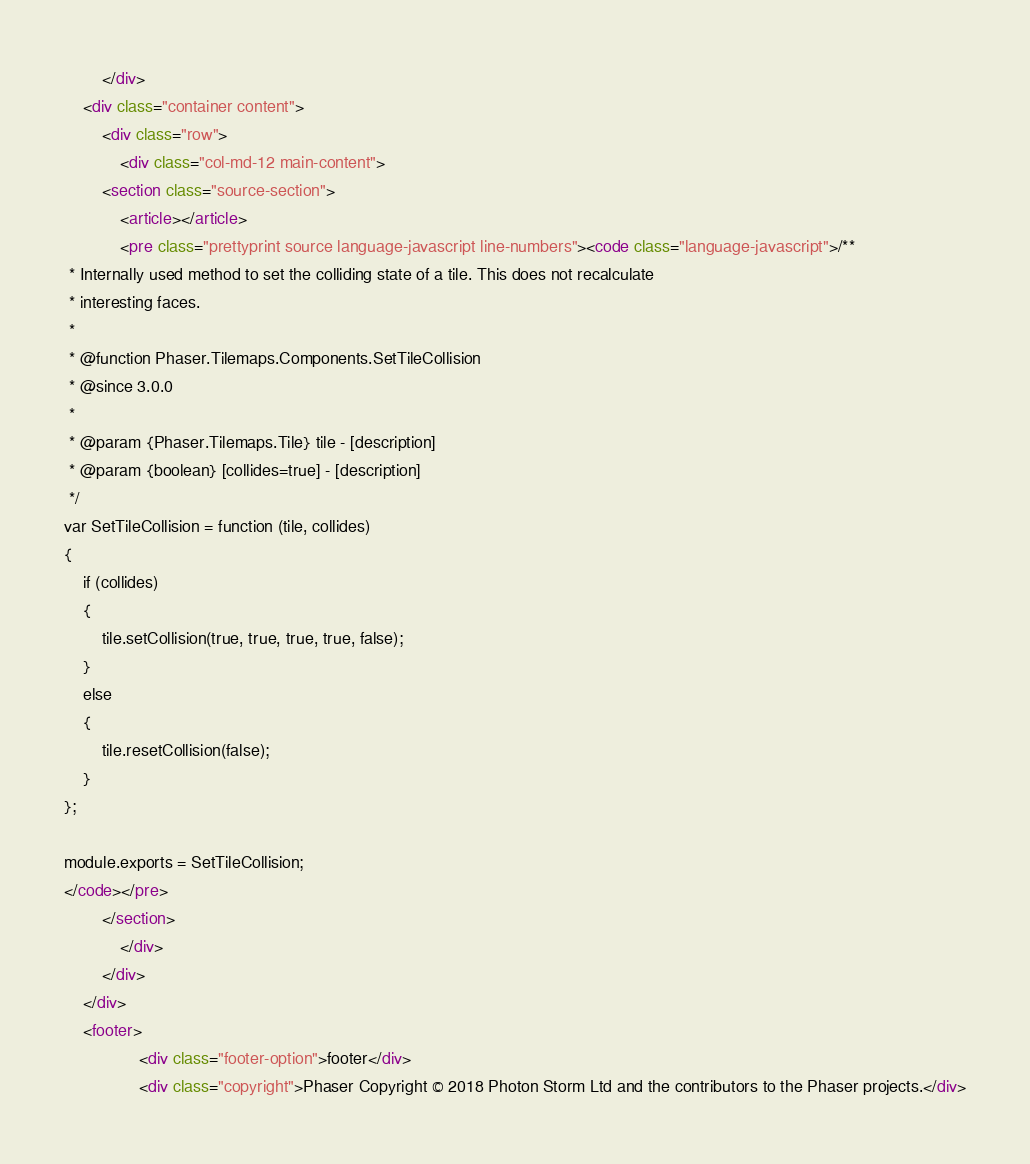Convert code to text. <code><loc_0><loc_0><loc_500><loc_500><_HTML_>		</div>
	<div class="container content">
		<div class="row">
			<div class="col-md-12 main-content">
		<section class="source-section">
			<article></article>
			<pre class="prettyprint source language-javascript line-numbers"><code class="language-javascript">/**
 * Internally used method to set the colliding state of a tile. This does not recalculate
 * interesting faces.
 *
 * @function Phaser.Tilemaps.Components.SetTileCollision
 * @since 3.0.0
 *
 * @param {Phaser.Tilemaps.Tile} tile - [description]
 * @param {boolean} [collides=true] - [description]
 */
var SetTileCollision = function (tile, collides)
{
    if (collides)
    {
        tile.setCollision(true, true, true, true, false);
    }
    else
    {
        tile.resetCollision(false);
    }
};

module.exports = SetTileCollision;
</code></pre>
		</section>
			</div>
		</div>
	</div>
	<footer>
				<div class="footer-option">footer</div>
				<div class="copyright">Phaser Copyright © 2018 Photon Storm Ltd and the contributors to the Phaser projects.</div></code> 